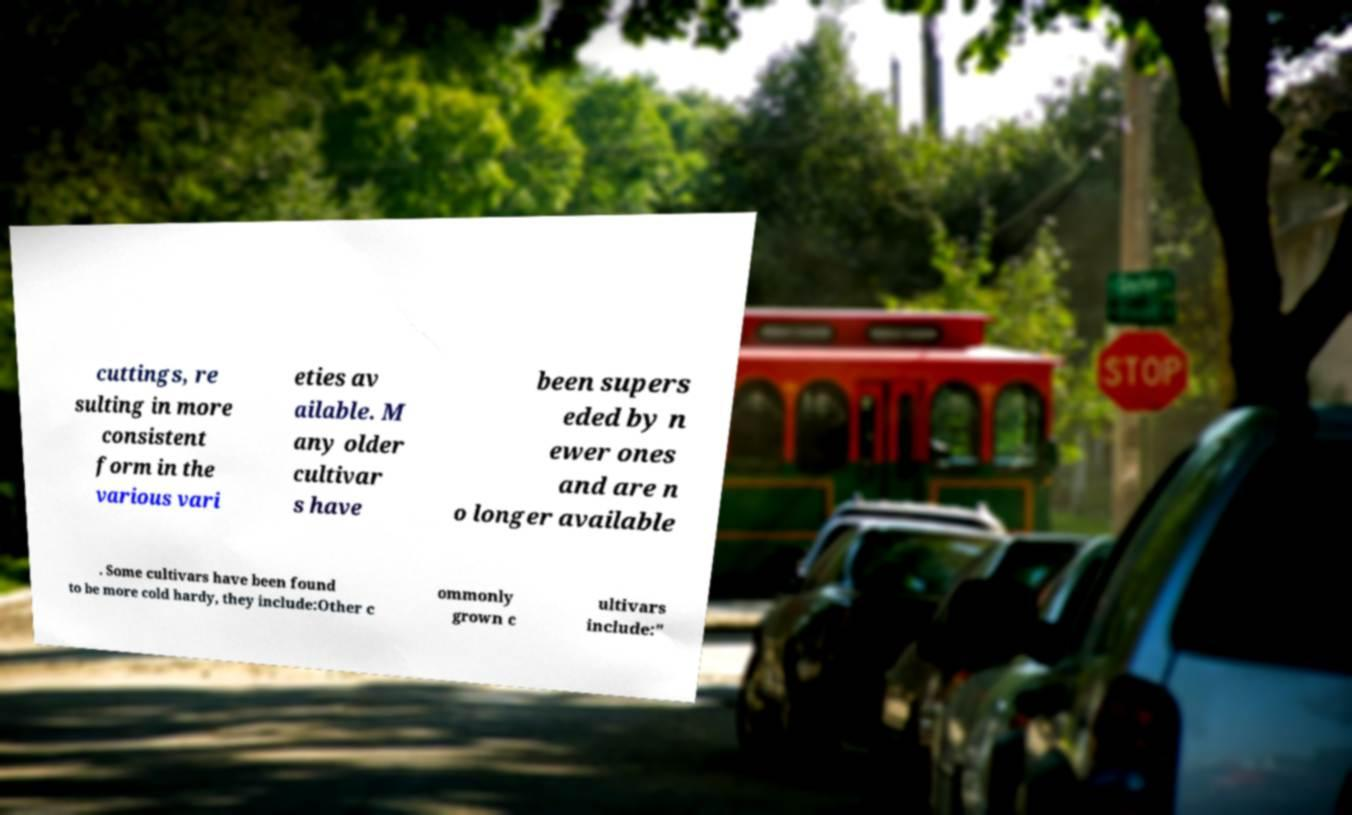What messages or text are displayed in this image? I need them in a readable, typed format. cuttings, re sulting in more consistent form in the various vari eties av ailable. M any older cultivar s have been supers eded by n ewer ones and are n o longer available . Some cultivars have been found to be more cold hardy, they include:Other c ommonly grown c ultivars include:" 